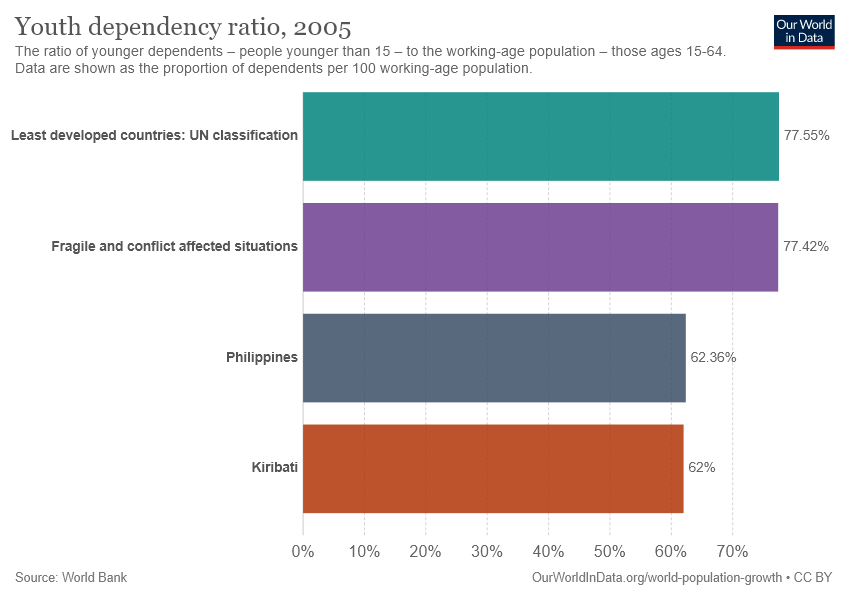Specify some key components in this picture. The smallest bar is valued at 62. The sum of the smallest two bars is not twice the value of the largest bar. 